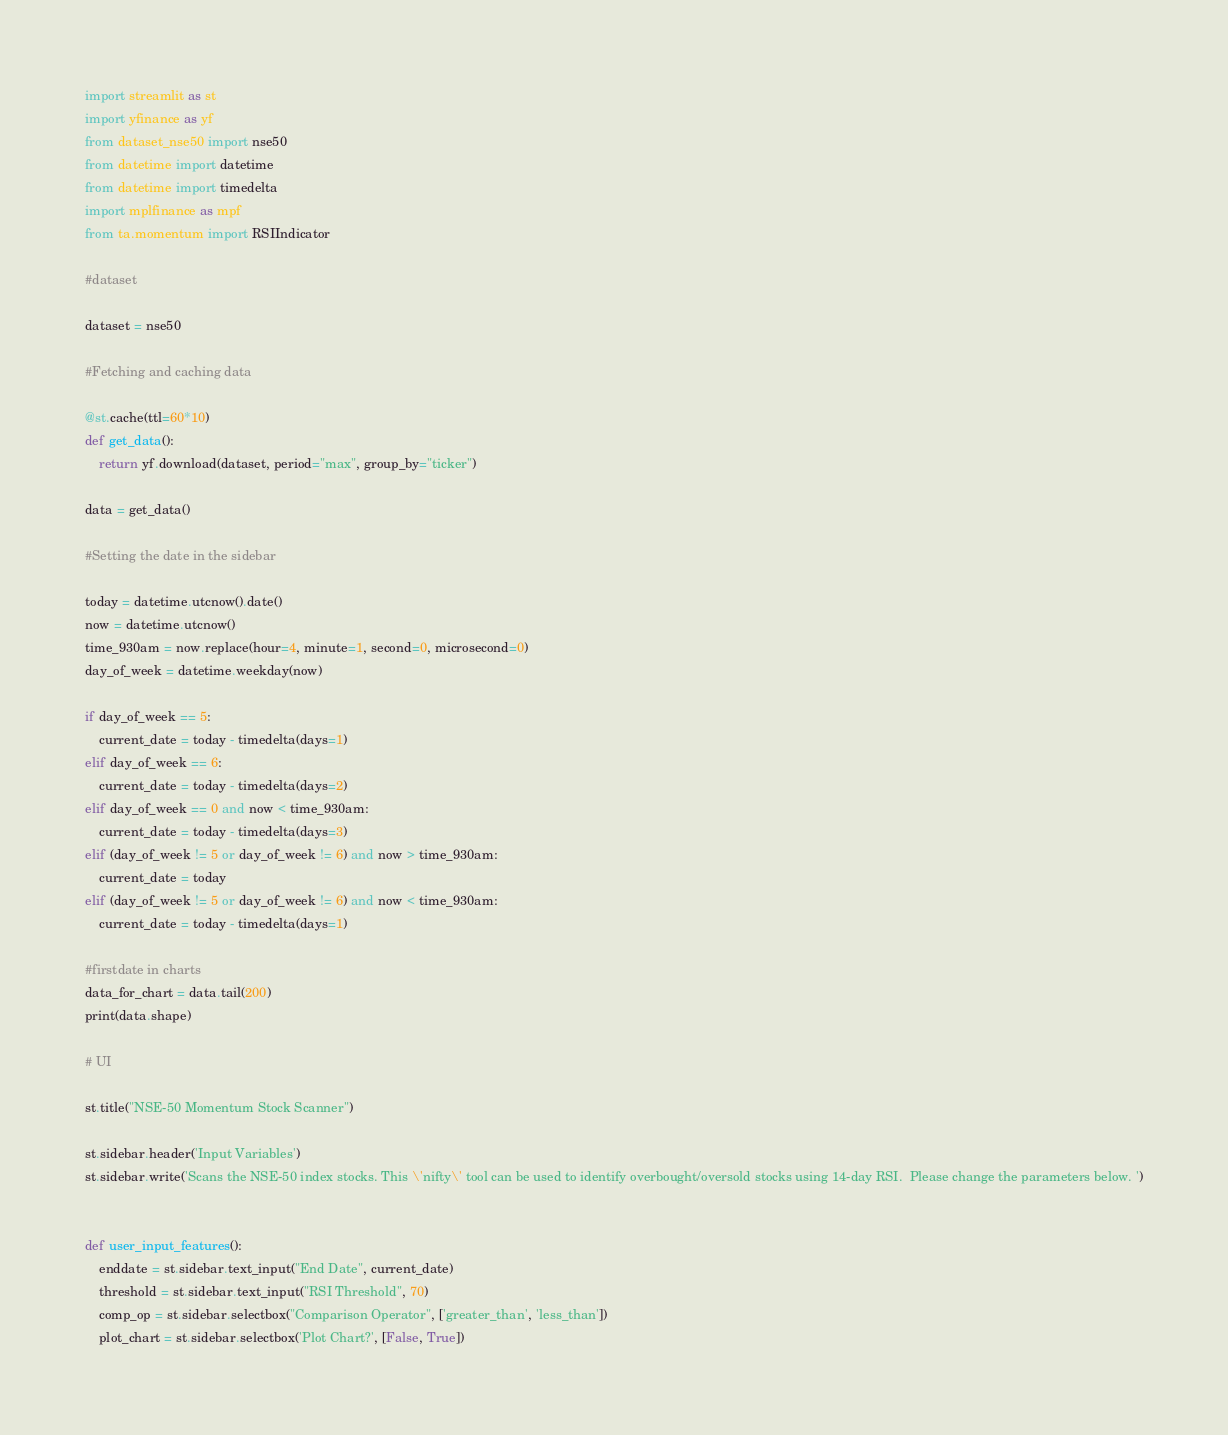Convert code to text. <code><loc_0><loc_0><loc_500><loc_500><_Python_>import streamlit as st
import yfinance as yf
from dataset_nse50 import nse50
from datetime import datetime
from datetime import timedelta
import mplfinance as mpf
from ta.momentum import RSIIndicator

#dataset

dataset = nse50

#Fetching and caching data

@st.cache(ttl=60*10)
def get_data():
    return yf.download(dataset, period="max", group_by="ticker")

data = get_data()

#Setting the date in the sidebar

today = datetime.utcnow().date()
now = datetime.utcnow()
time_930am = now.replace(hour=4, minute=1, second=0, microsecond=0)
day_of_week = datetime.weekday(now)

if day_of_week == 5:
    current_date = today - timedelta(days=1)
elif day_of_week == 6:
    current_date = today - timedelta(days=2)
elif day_of_week == 0 and now < time_930am:
    current_date = today - timedelta(days=3)
elif (day_of_week != 5 or day_of_week != 6) and now > time_930am:
    current_date = today
elif (day_of_week != 5 or day_of_week != 6) and now < time_930am:
    current_date = today - timedelta(days=1)

#firstdate in charts
data_for_chart = data.tail(200)
print(data.shape)

# UI

st.title("NSE-50 Momentum Stock Scanner")

st.sidebar.header('Input Variables')
st.sidebar.write('Scans the NSE-50 index stocks. This \'nifty\' tool can be used to identify overbought/oversold stocks using 14-day RSI.  Please change the parameters below. ')


def user_input_features():
    enddate = st.sidebar.text_input("End Date", current_date)
    threshold = st.sidebar.text_input("RSI Threshold", 70)
    comp_op = st.sidebar.selectbox("Comparison Operator", ['greater_than', 'less_than'])
    plot_chart = st.sidebar.selectbox('Plot Chart?', [False, True])</code> 